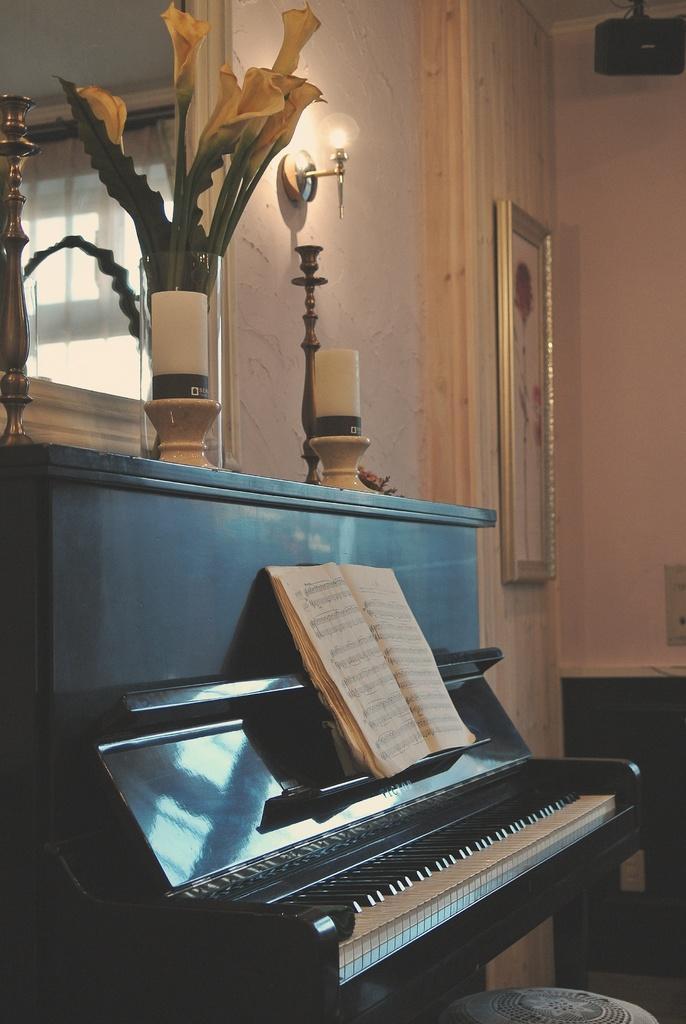Can you describe this image briefly? There is a piano and this is book. On the background there is a wall and this is frame. This is a plant and there is a light. 